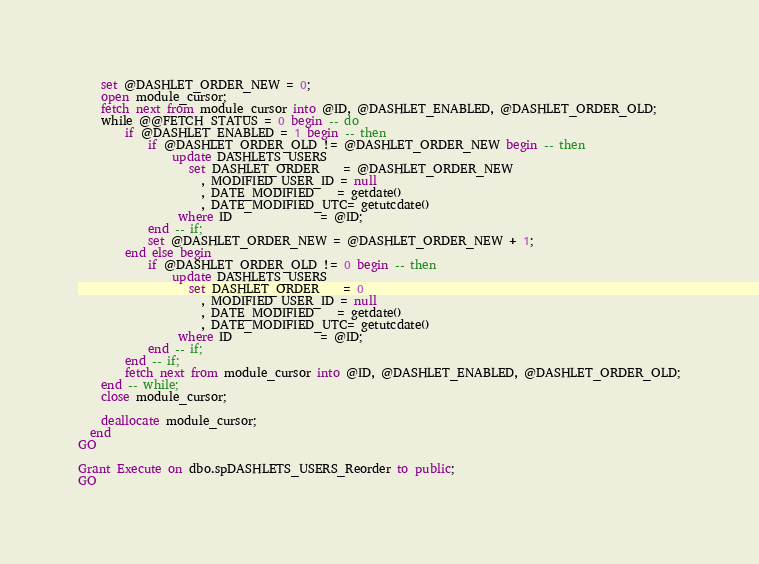<code> <loc_0><loc_0><loc_500><loc_500><_SQL_>	set @DASHLET_ORDER_NEW = 0;
	open module_cursor;
	fetch next from module_cursor into @ID, @DASHLET_ENABLED, @DASHLET_ORDER_OLD;
	while @@FETCH_STATUS = 0 begin -- do
		if @DASHLET_ENABLED = 1 begin -- then
			if @DASHLET_ORDER_OLD != @DASHLET_ORDER_NEW begin -- then
				update DASHLETS_USERS
				   set DASHLET_ORDER    = @DASHLET_ORDER_NEW
				     , MODIFIED_USER_ID = null
				     , DATE_MODIFIED    = getdate()
				     , DATE_MODIFIED_UTC= getutcdate()
				 where ID               = @ID;
			end -- if;
			set @DASHLET_ORDER_NEW = @DASHLET_ORDER_NEW + 1;
		end else begin
			if @DASHLET_ORDER_OLD != 0 begin -- then
				update DASHLETS_USERS
				   set DASHLET_ORDER    = 0
				     , MODIFIED_USER_ID = null
				     , DATE_MODIFIED    = getdate()
				     , DATE_MODIFIED_UTC= getutcdate()
				 where ID               = @ID;
			end -- if;
		end -- if;
		fetch next from module_cursor into @ID, @DASHLET_ENABLED, @DASHLET_ORDER_OLD;
	end -- while;
	close module_cursor;

	deallocate module_cursor;
  end
GO

Grant Execute on dbo.spDASHLETS_USERS_Reorder to public;
GO

</code> 